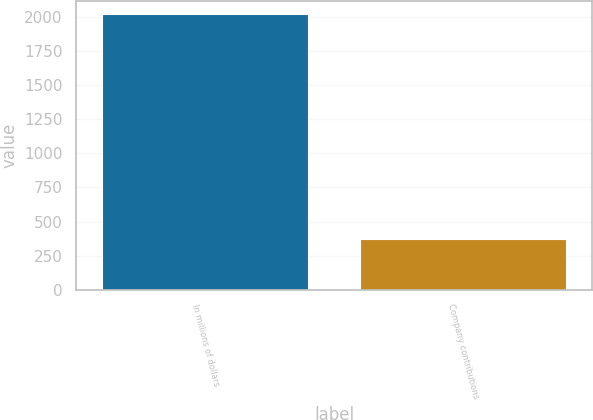Convert chart to OTSL. <chart><loc_0><loc_0><loc_500><loc_500><bar_chart><fcel>In millions of dollars<fcel>Company contributions<nl><fcel>2016<fcel>371<nl></chart> 